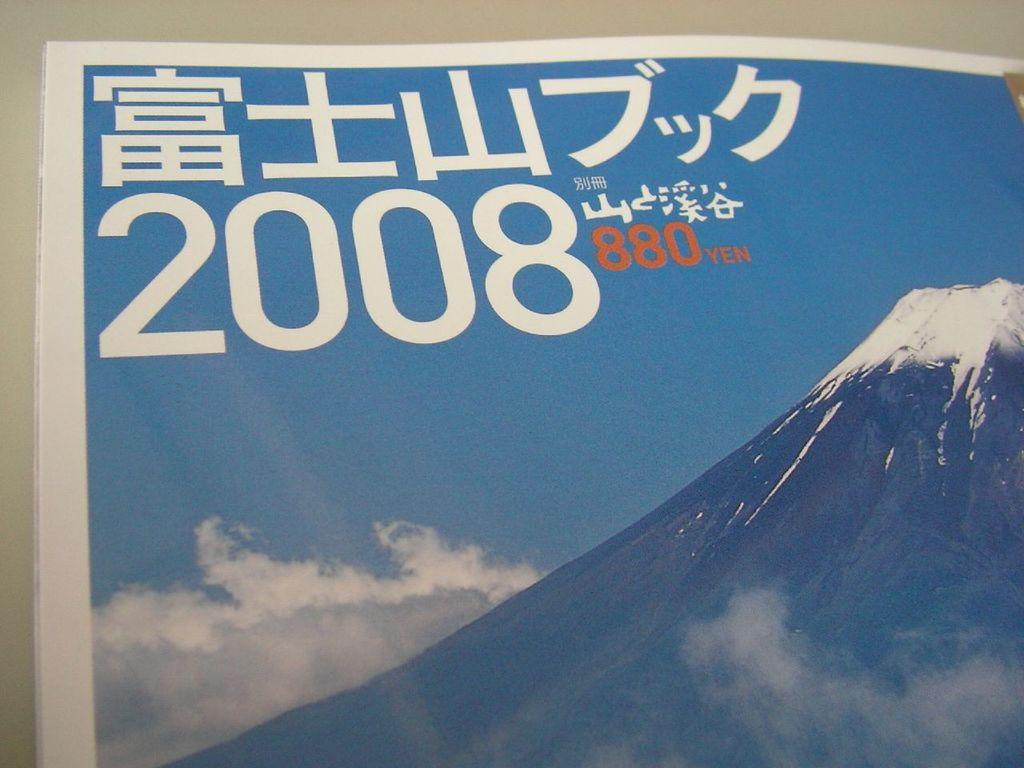<image>
Describe the image concisely. A picture of a mountain, in the upper left, the year 2008. 